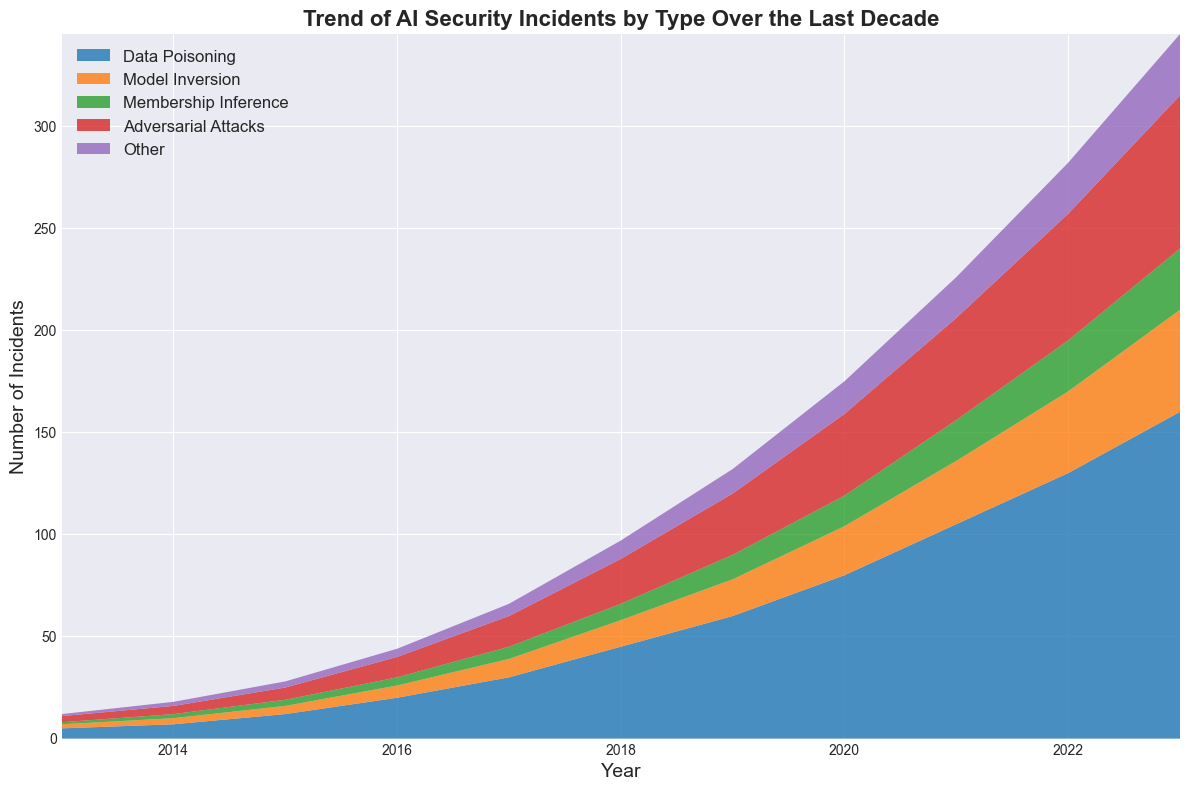What's the general trend of AI security incidents over the last decade? The area chart shows a noticeable increase in the total number of AI security incidents across all types from 2013 to 2023. This is evident as the height of the stacked areas cumulatively grows every year.
Answer: Increasing Which type of incident saw the most growth between 2013 and 2023? Looking at the relative heights of the colored areas, "Data Poisoning" shows the most significant increase in the number of incidents compared to other types between 2013 and 2023.
Answer: Data Poisoning Comparing the total number of incidents in 2023, which two types of incidents have the closest values? By visually comparing the stacked areas in 2023, "Membership Inference" and "Other" appear to have the closest values as their respective heights look similar.
Answer: Membership Inference and Other In which year did "Model Inversion" incidents first surpass "Membership Inference" incidents? Observing the crossover points of the respective colored areas, "Model Inversion" incidents surpassed "Membership Inference" incidents first in 2017.
Answer: 2017 What was the approximate number of "Adversarial Attacks" incidents in 2020, and how does it compare to "Data Poisoning" in the same year? In 2020, "Adversarial Attacks" incidents are around 40, while "Data Poisoning" incidents are approximately 80. Hence, "Data Poisoning" incidents are about double the count of "Adversarial Attacks".
Answer: 40, double Visually, which type of incidents occupies the smallest area on the chart for the entire decade? By examining the overall sizes of the colored areas, the "Other" category consistently occupies the smallest area throughout the decade.
Answer: Other How many total incidents were recorded in 2015 across all types? Summing up the values in the data for the year 2015: 12 (Data Poisoning) + 4 (Model Inversion) + 3 (Membership Inference) + 6 (Adversarial Attacks) + 3 (Other) = 28 incidents.
Answer: 28 In which years did incidents of "Adversarial Attacks" increase at the fastest rate, and by approximately how much? Notable increases are observed between 2017 to 2018 (15 to 22 incidents, an increase of 7) and 2022 to 2023 (62 to 75 incidents, an increase of 13). The largest single increase appears to be from 2022 to 2023 by 13 incidents.
Answer: 2017-2018 and 2022-2023, 13 What is the combined total of incidents involving "Data Poisoning" and "Model Inversion" in 2019? Adding the incidents from the two categories in 2019: 60 (Data Poisoning) + 18 (Model Inversion) = 78 incidents.
Answer: 78 Which incident type has the highest number in 2023, and what is its count? From the chart, the highest area at 2023 belongs to "Data Poisoning," with a count of 160 incidents.
Answer: Data Poisoning, 160 